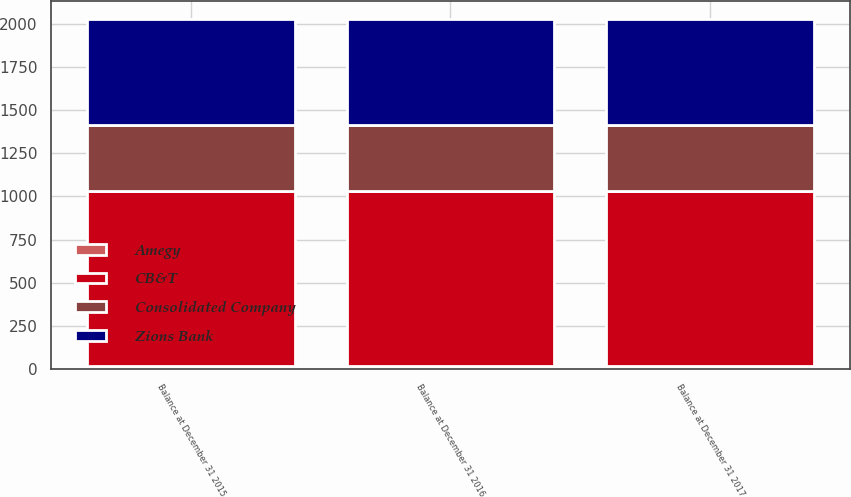Convert chart. <chart><loc_0><loc_0><loc_500><loc_500><stacked_bar_chart><ecel><fcel>Balance at December 31 2015<fcel>Balance at December 31 2016<fcel>Balance at December 31 2017<nl><fcel>Amegy<fcel>20<fcel>20<fcel>20<nl><fcel>Consolidated Company<fcel>379<fcel>379<fcel>379<nl><fcel>Zions Bank<fcel>615<fcel>615<fcel>615<nl><fcel>CB&T<fcel>1014<fcel>1014<fcel>1014<nl></chart> 